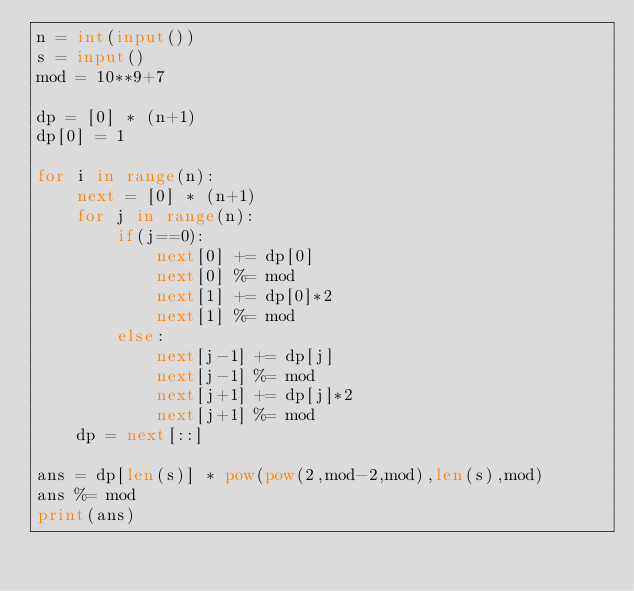Convert code to text. <code><loc_0><loc_0><loc_500><loc_500><_Python_>n = int(input())
s = input()
mod = 10**9+7

dp = [0] * (n+1)
dp[0] = 1

for i in range(n):
    next = [0] * (n+1)
    for j in range(n):
        if(j==0):
            next[0] += dp[0]
            next[0] %= mod
            next[1] += dp[0]*2
            next[1] %= mod
        else:
            next[j-1] += dp[j]
            next[j-1] %= mod
            next[j+1] += dp[j]*2
            next[j+1] %= mod
    dp = next[::]

ans = dp[len(s)] * pow(pow(2,mod-2,mod),len(s),mod)
ans %= mod
print(ans)</code> 